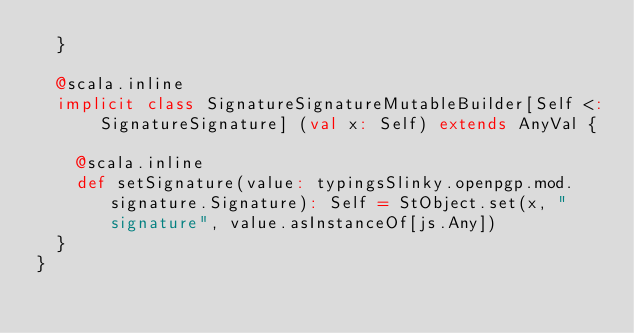<code> <loc_0><loc_0><loc_500><loc_500><_Scala_>  }
  
  @scala.inline
  implicit class SignatureSignatureMutableBuilder[Self <: SignatureSignature] (val x: Self) extends AnyVal {
    
    @scala.inline
    def setSignature(value: typingsSlinky.openpgp.mod.signature.Signature): Self = StObject.set(x, "signature", value.asInstanceOf[js.Any])
  }
}
</code> 